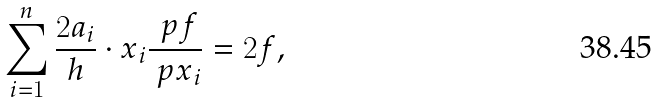Convert formula to latex. <formula><loc_0><loc_0><loc_500><loc_500>\sum _ { i = 1 } ^ { n } \frac { 2 a _ { i } } { h } \cdot x _ { i } \frac { \ p f } { \ p x _ { i } } = 2 f ,</formula> 